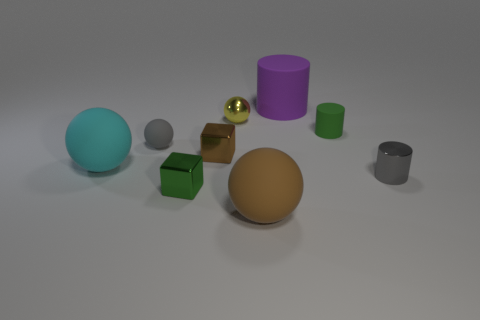Subtract all gray spheres. Subtract all cyan blocks. How many spheres are left? 3 Add 1 yellow rubber blocks. How many objects exist? 10 Subtract all spheres. How many objects are left? 5 Subtract 1 cyan spheres. How many objects are left? 8 Subtract all small red balls. Subtract all green metallic objects. How many objects are left? 8 Add 2 small yellow balls. How many small yellow balls are left? 3 Add 3 brown matte objects. How many brown matte objects exist? 4 